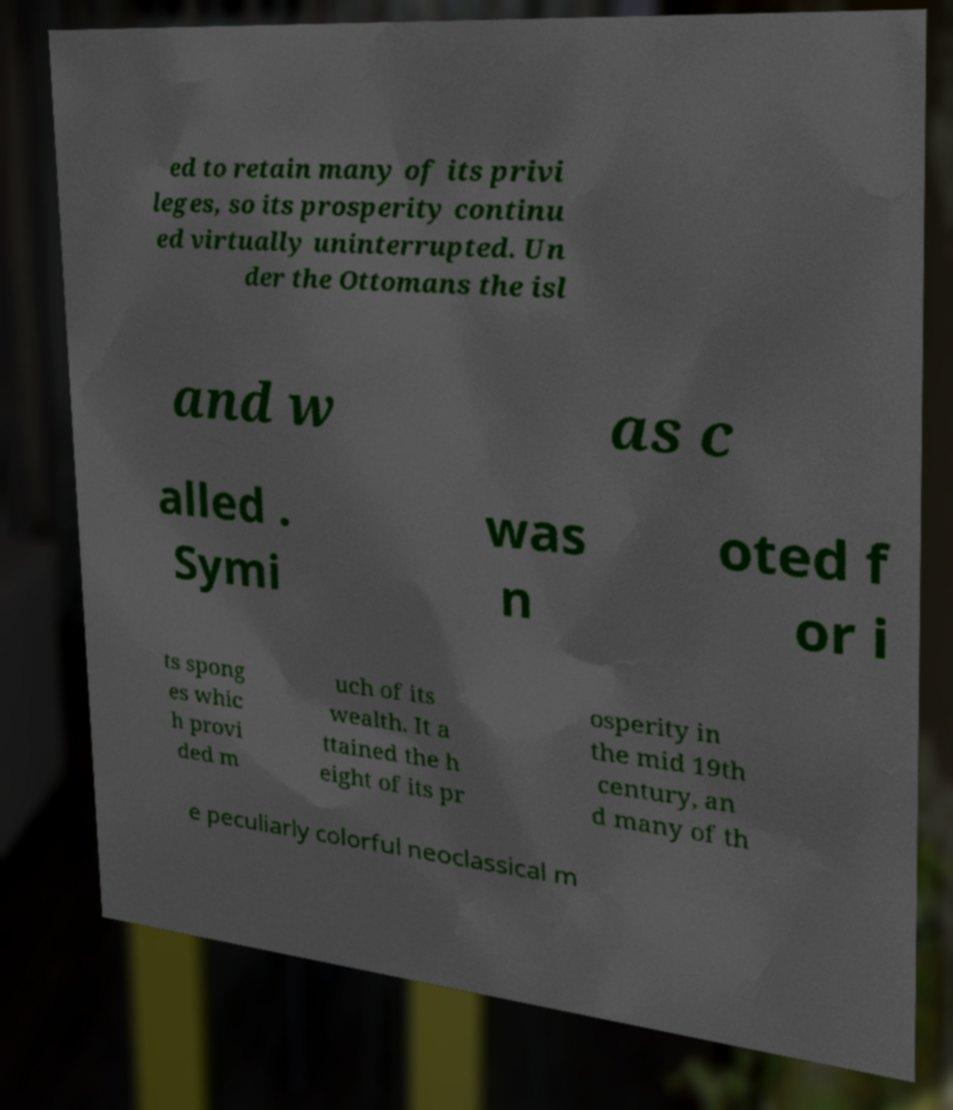Can you read and provide the text displayed in the image?This photo seems to have some interesting text. Can you extract and type it out for me? ed to retain many of its privi leges, so its prosperity continu ed virtually uninterrupted. Un der the Ottomans the isl and w as c alled . Symi was n oted f or i ts spong es whic h provi ded m uch of its wealth. It a ttained the h eight of its pr osperity in the mid 19th century, an d many of th e peculiarly colorful neoclassical m 